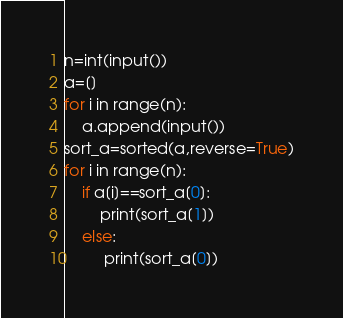Convert code to text. <code><loc_0><loc_0><loc_500><loc_500><_Python_>n=int(input())
a=[]
for i in range(n):
    a.append(input())
sort_a=sorted(a,reverse=True)
for i in range(n):
    if a[i]==sort_a[0]:
        print(sort_a[1])
    else:
         print(sort_a[0])</code> 